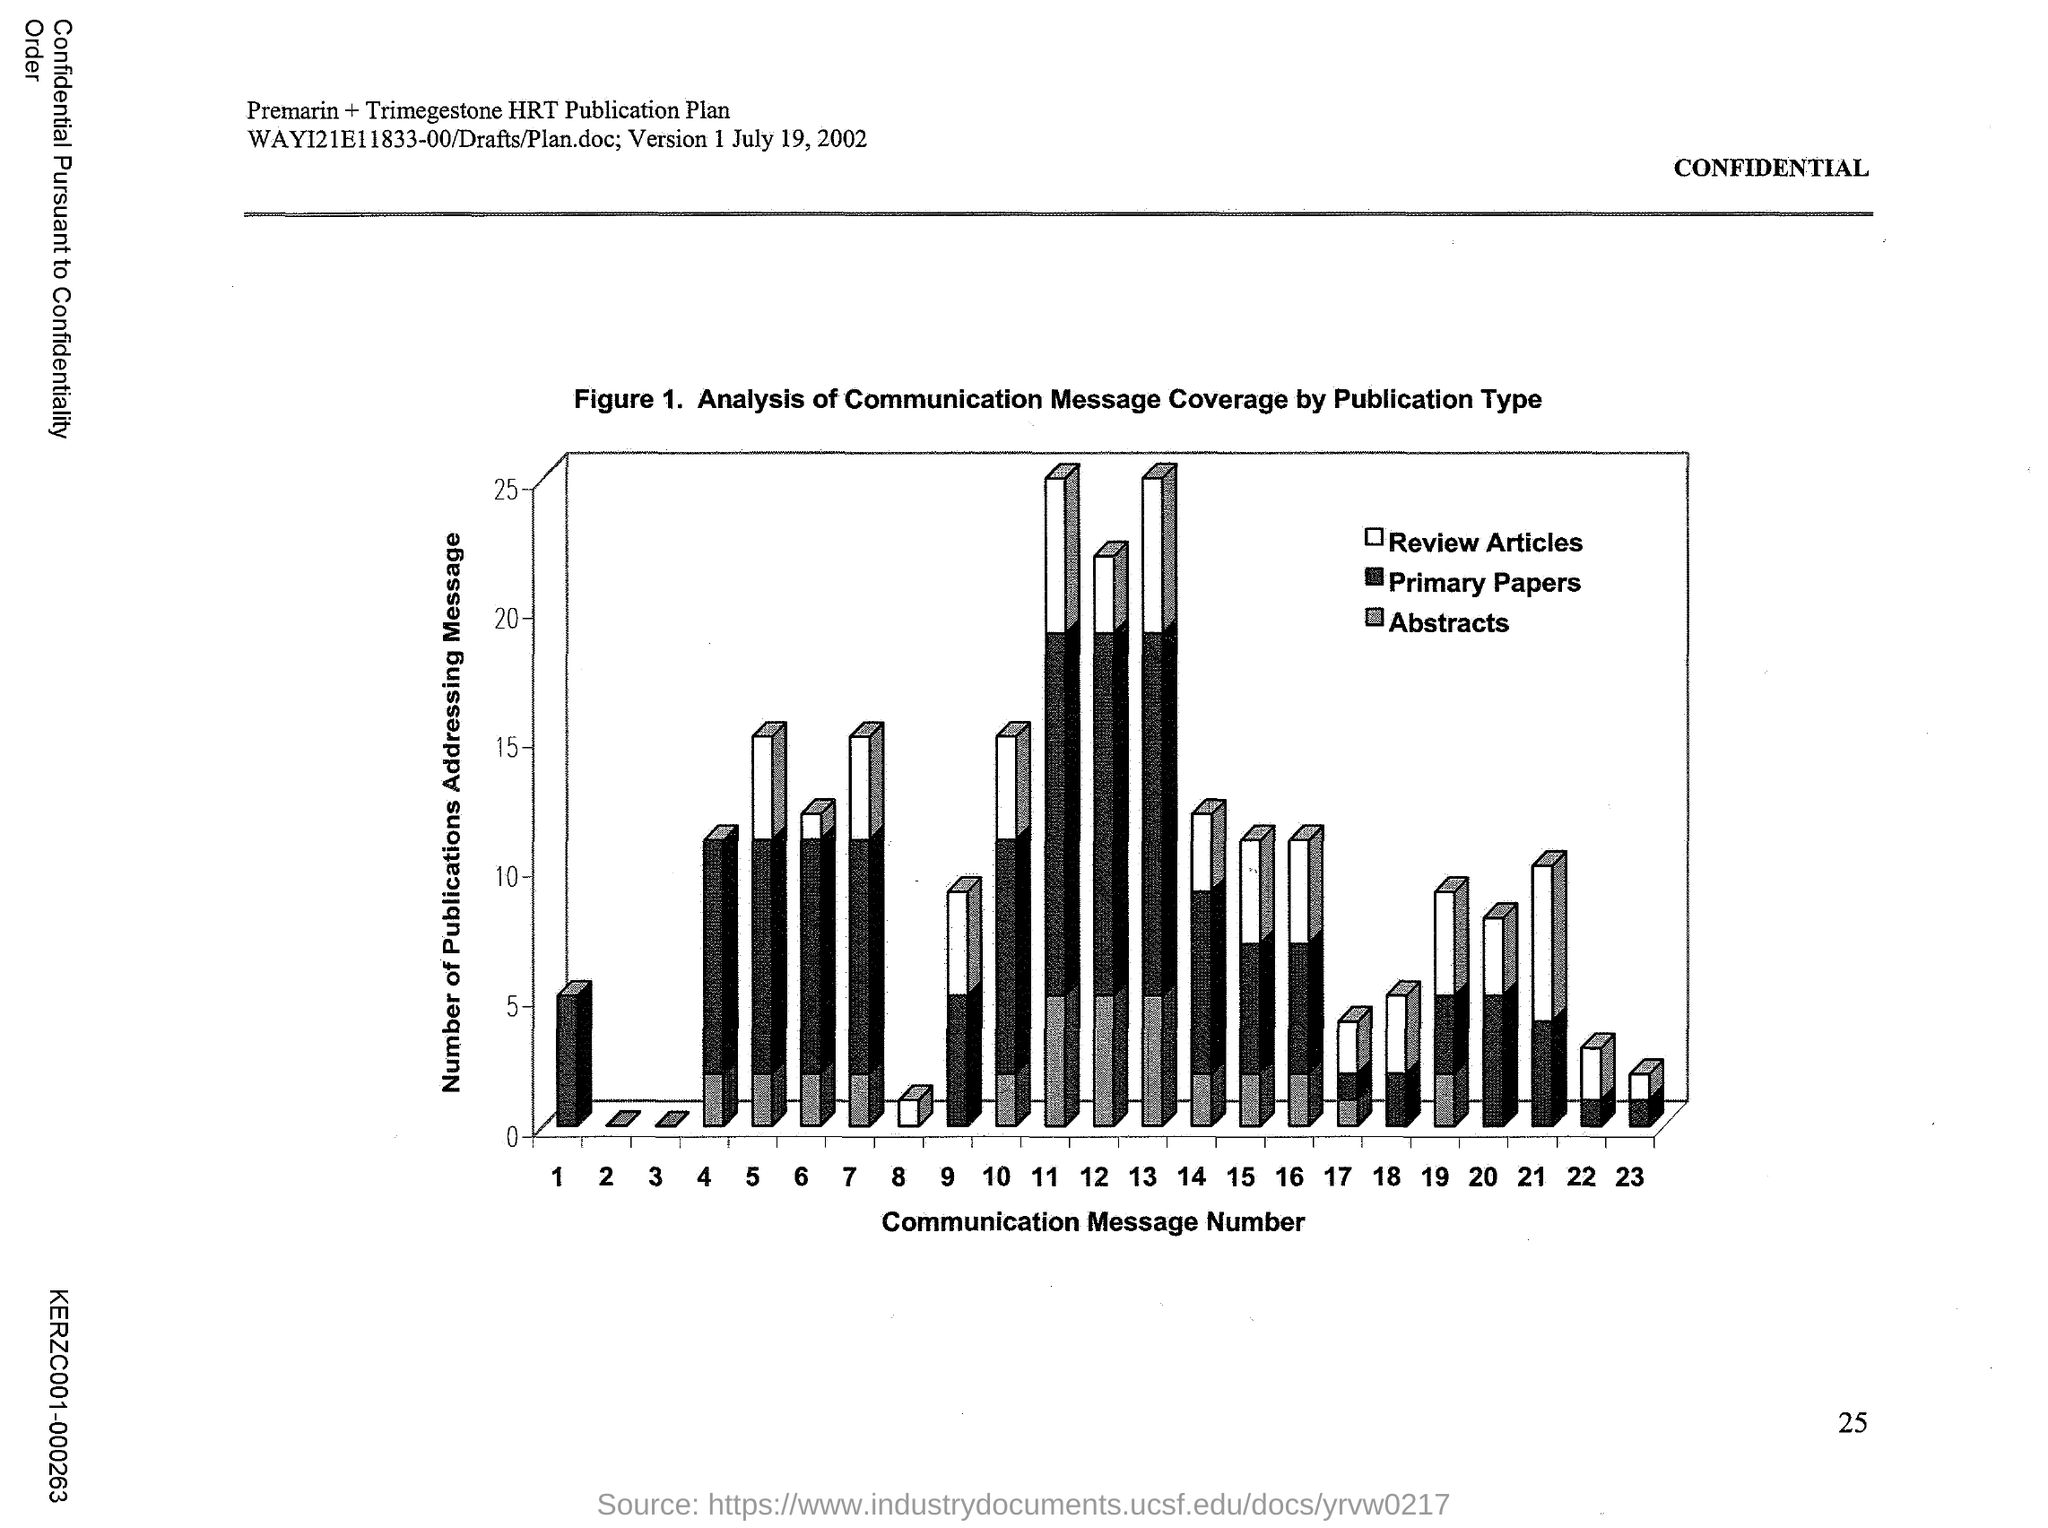Highlight a few significant elements in this photo. Figure 1. shows the relationship between communication message number and the effectiveness of the message in reducing uncertainty. The x-axis represents the communication message number, while the y-axis represents the level of effectiveness. The graph demonstrates a positive correlation between the two variables, indicating that as the number of communication messages increases, the effectiveness of the messages in reducing uncertainty also increases. Figure 1 in this document represents an analysis of communication message coverage by publication type. The y-axis of Figure 1 represents the number of publications addressing a specific message. 